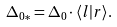<formula> <loc_0><loc_0><loc_500><loc_500>\Delta _ { 0 \ast } = \Delta _ { 0 } \cdot \langle l | r \rangle .</formula> 